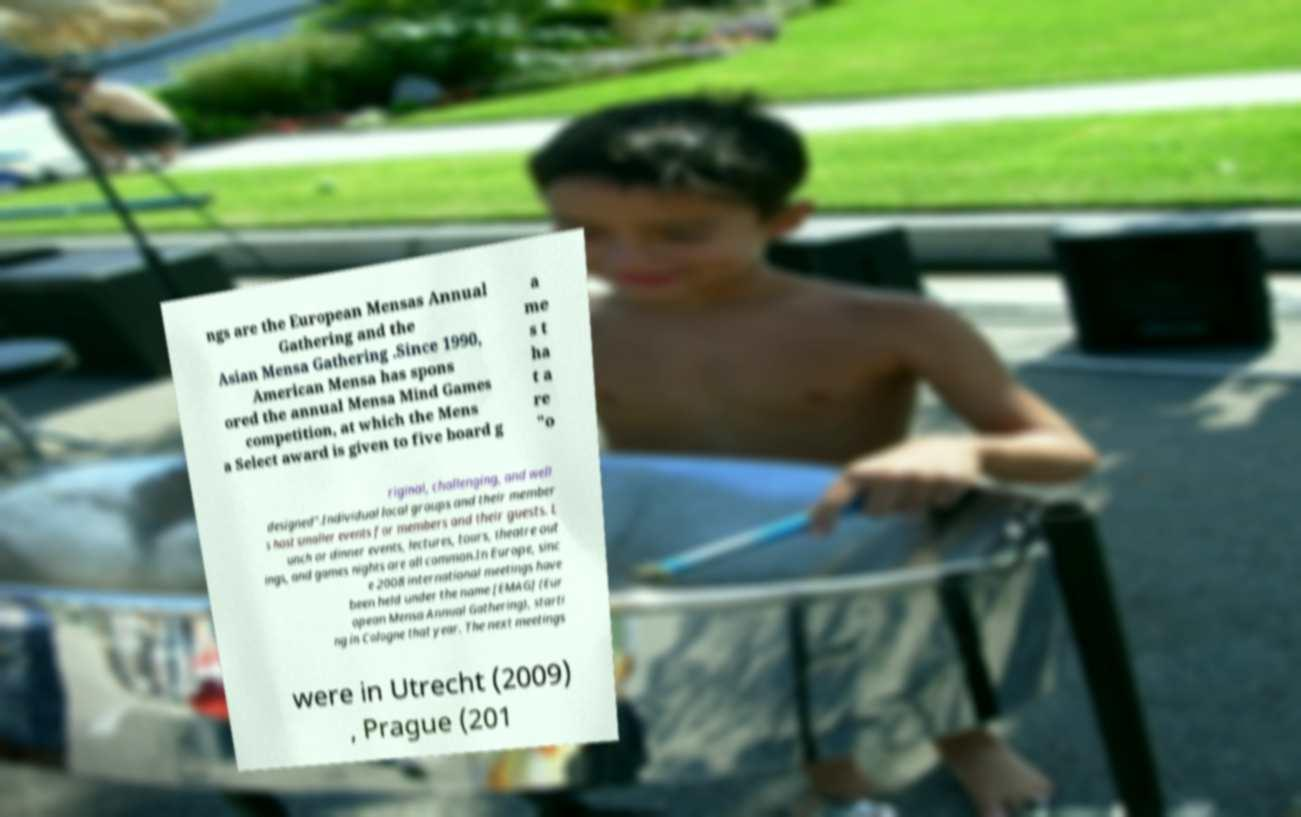Can you accurately transcribe the text from the provided image for me? ngs are the European Mensas Annual Gathering and the Asian Mensa Gathering .Since 1990, American Mensa has spons ored the annual Mensa Mind Games competition, at which the Mens a Select award is given to five board g a me s t ha t a re "o riginal, challenging, and well designed".Individual local groups and their member s host smaller events for members and their guests. L unch or dinner events, lectures, tours, theatre out ings, and games nights are all common.In Europe, sinc e 2008 international meetings have been held under the name [EMAG] (Eur opean Mensa Annual Gathering), starti ng in Cologne that year. The next meetings were in Utrecht (2009) , Prague (201 